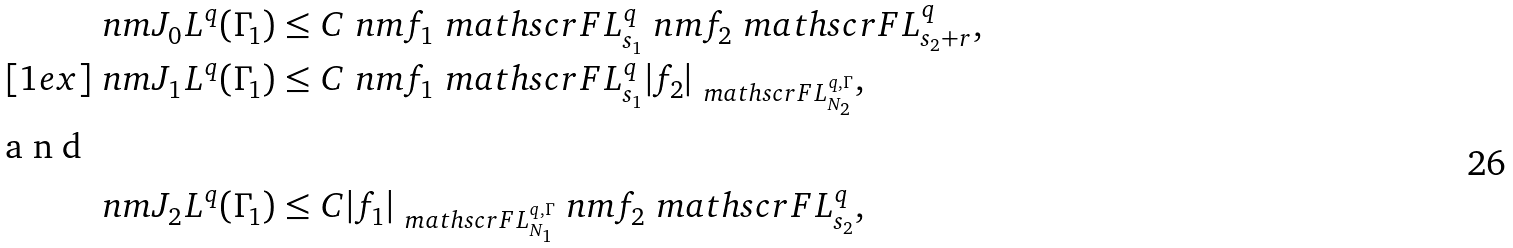<formula> <loc_0><loc_0><loc_500><loc_500>\ n m { J _ { 0 } } { L ^ { q } ( \Gamma _ { 1 } ) } & \leq C \ n m { f _ { 1 } } { \ m a t h s c r F L ^ { q } _ { s _ { 1 } } } \ n m { f _ { 2 } } { \ m a t h s c r F L ^ { q } _ { s _ { 2 } + r } } , \\ [ 1 e x ] \ n m { J _ { 1 } } { L ^ { q } ( \Gamma _ { 1 } ) } & \leq C \ n m { f _ { 1 } } { \ m a t h s c r F L ^ { q } _ { s _ { 1 } } } | f _ { 2 } | _ { \ m a t h s c r F L ^ { q , \Gamma } _ { N _ { 2 } } } , \intertext { a n d } \ n m { J _ { 2 } } { L ^ { q } ( \Gamma _ { 1 } ) } & \leq C | f _ { 1 } | _ { \ m a t h s c r F L ^ { q , \Gamma } _ { N _ { 1 } } } \ n m { f _ { 2 } } { \ m a t h s c r F L ^ { q } _ { s _ { 2 } } } ,</formula> 